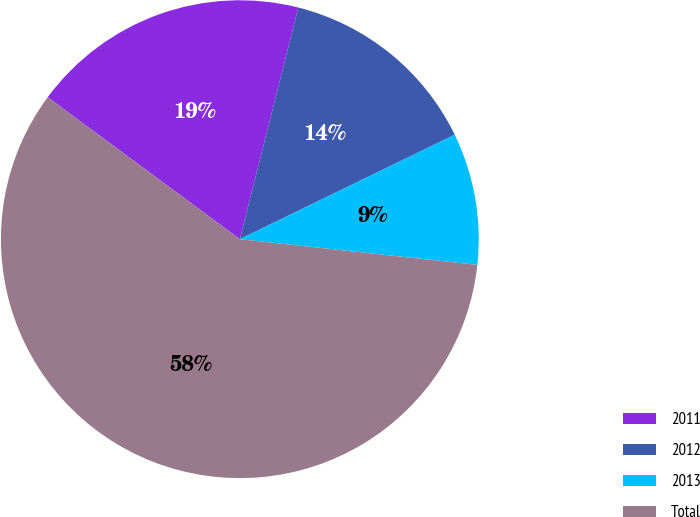Convert chart to OTSL. <chart><loc_0><loc_0><loc_500><loc_500><pie_chart><fcel>2011<fcel>2012<fcel>2013<fcel>Total<nl><fcel>18.81%<fcel>13.86%<fcel>8.92%<fcel>58.41%<nl></chart> 